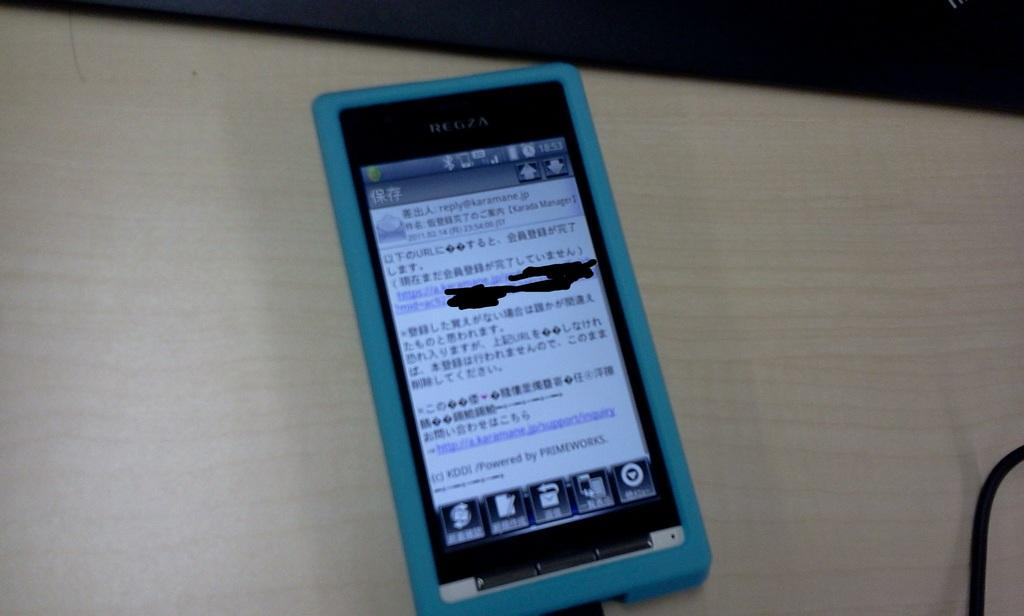<image>
Offer a succinct explanation of the picture presented. a cell phone with 18:53 written on it 